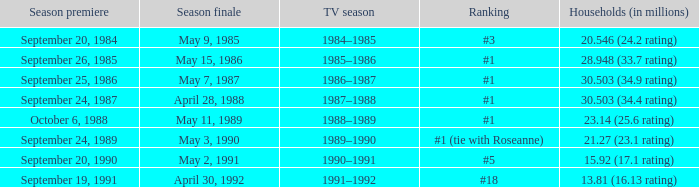Which TV season has a Season larger than 2, and a Ranking of #5? 1990–1991. 